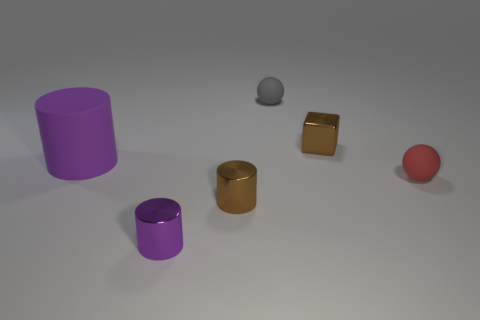Subtract all blue cubes. Subtract all red balls. How many cubes are left? 1 Add 4 brown metal cylinders. How many objects exist? 10 Subtract all blocks. How many objects are left? 5 Add 5 balls. How many balls are left? 7 Add 2 small red metallic cylinders. How many small red metallic cylinders exist? 2 Subtract 0 brown balls. How many objects are left? 6 Subtract all purple matte spheres. Subtract all red rubber spheres. How many objects are left? 5 